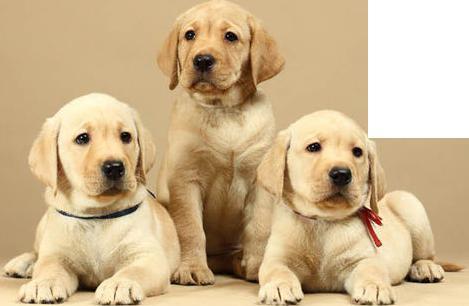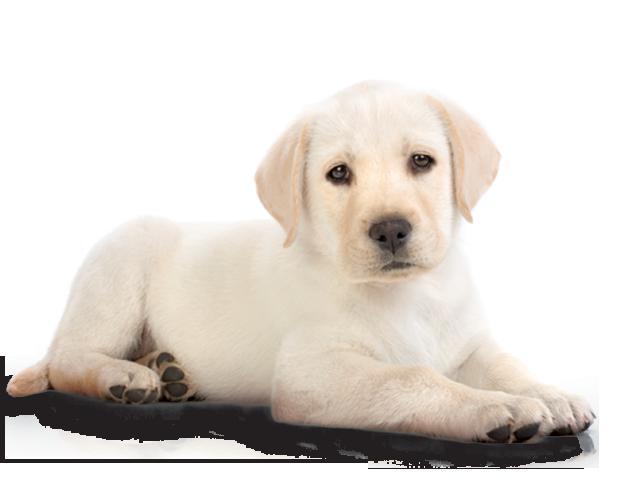The first image is the image on the left, the second image is the image on the right. For the images shown, is this caption "An image shows at least one reclining dog wearing something around its neck." true? Answer yes or no. Yes. The first image is the image on the left, the second image is the image on the right. Examine the images to the left and right. Is the description "In one if the pictures a puppy is laying on a dark cushion." accurate? Answer yes or no. Yes. 